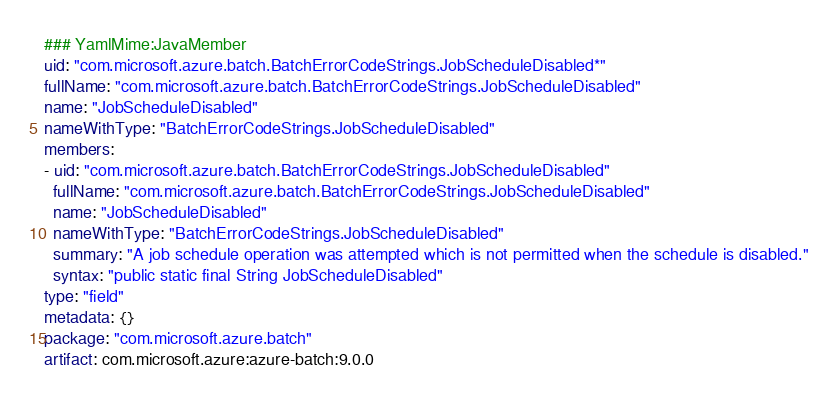Convert code to text. <code><loc_0><loc_0><loc_500><loc_500><_YAML_>### YamlMime:JavaMember
uid: "com.microsoft.azure.batch.BatchErrorCodeStrings.JobScheduleDisabled*"
fullName: "com.microsoft.azure.batch.BatchErrorCodeStrings.JobScheduleDisabled"
name: "JobScheduleDisabled"
nameWithType: "BatchErrorCodeStrings.JobScheduleDisabled"
members:
- uid: "com.microsoft.azure.batch.BatchErrorCodeStrings.JobScheduleDisabled"
  fullName: "com.microsoft.azure.batch.BatchErrorCodeStrings.JobScheduleDisabled"
  name: "JobScheduleDisabled"
  nameWithType: "BatchErrorCodeStrings.JobScheduleDisabled"
  summary: "A job schedule operation was attempted which is not permitted when the schedule is disabled."
  syntax: "public static final String JobScheduleDisabled"
type: "field"
metadata: {}
package: "com.microsoft.azure.batch"
artifact: com.microsoft.azure:azure-batch:9.0.0
</code> 